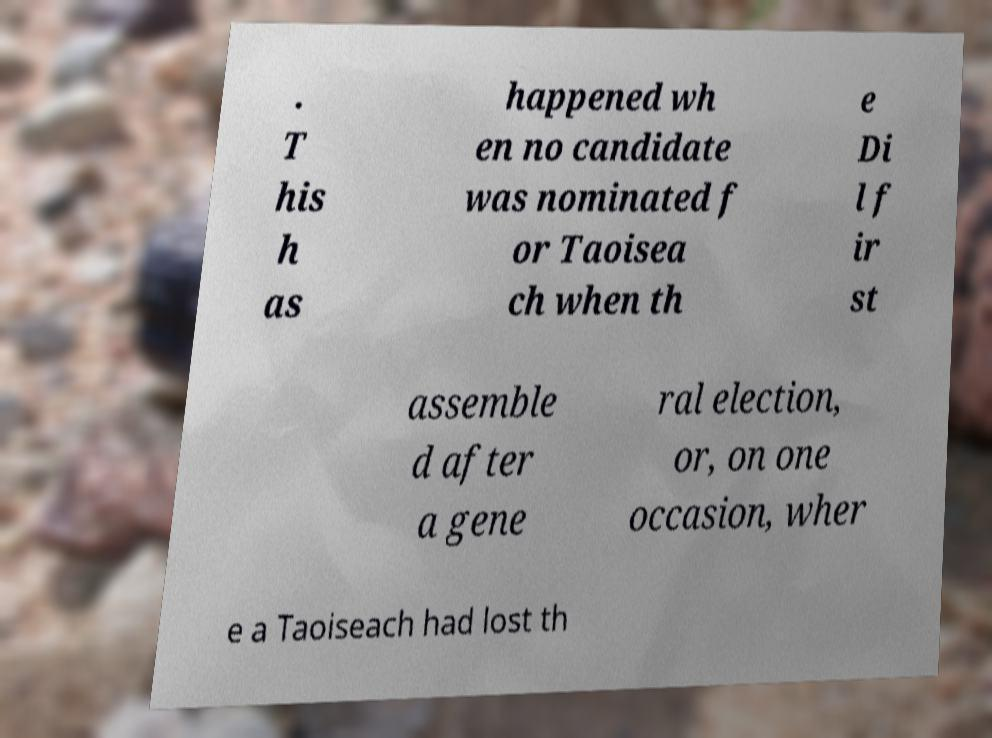For documentation purposes, I need the text within this image transcribed. Could you provide that? . T his h as happened wh en no candidate was nominated f or Taoisea ch when th e Di l f ir st assemble d after a gene ral election, or, on one occasion, wher e a Taoiseach had lost th 